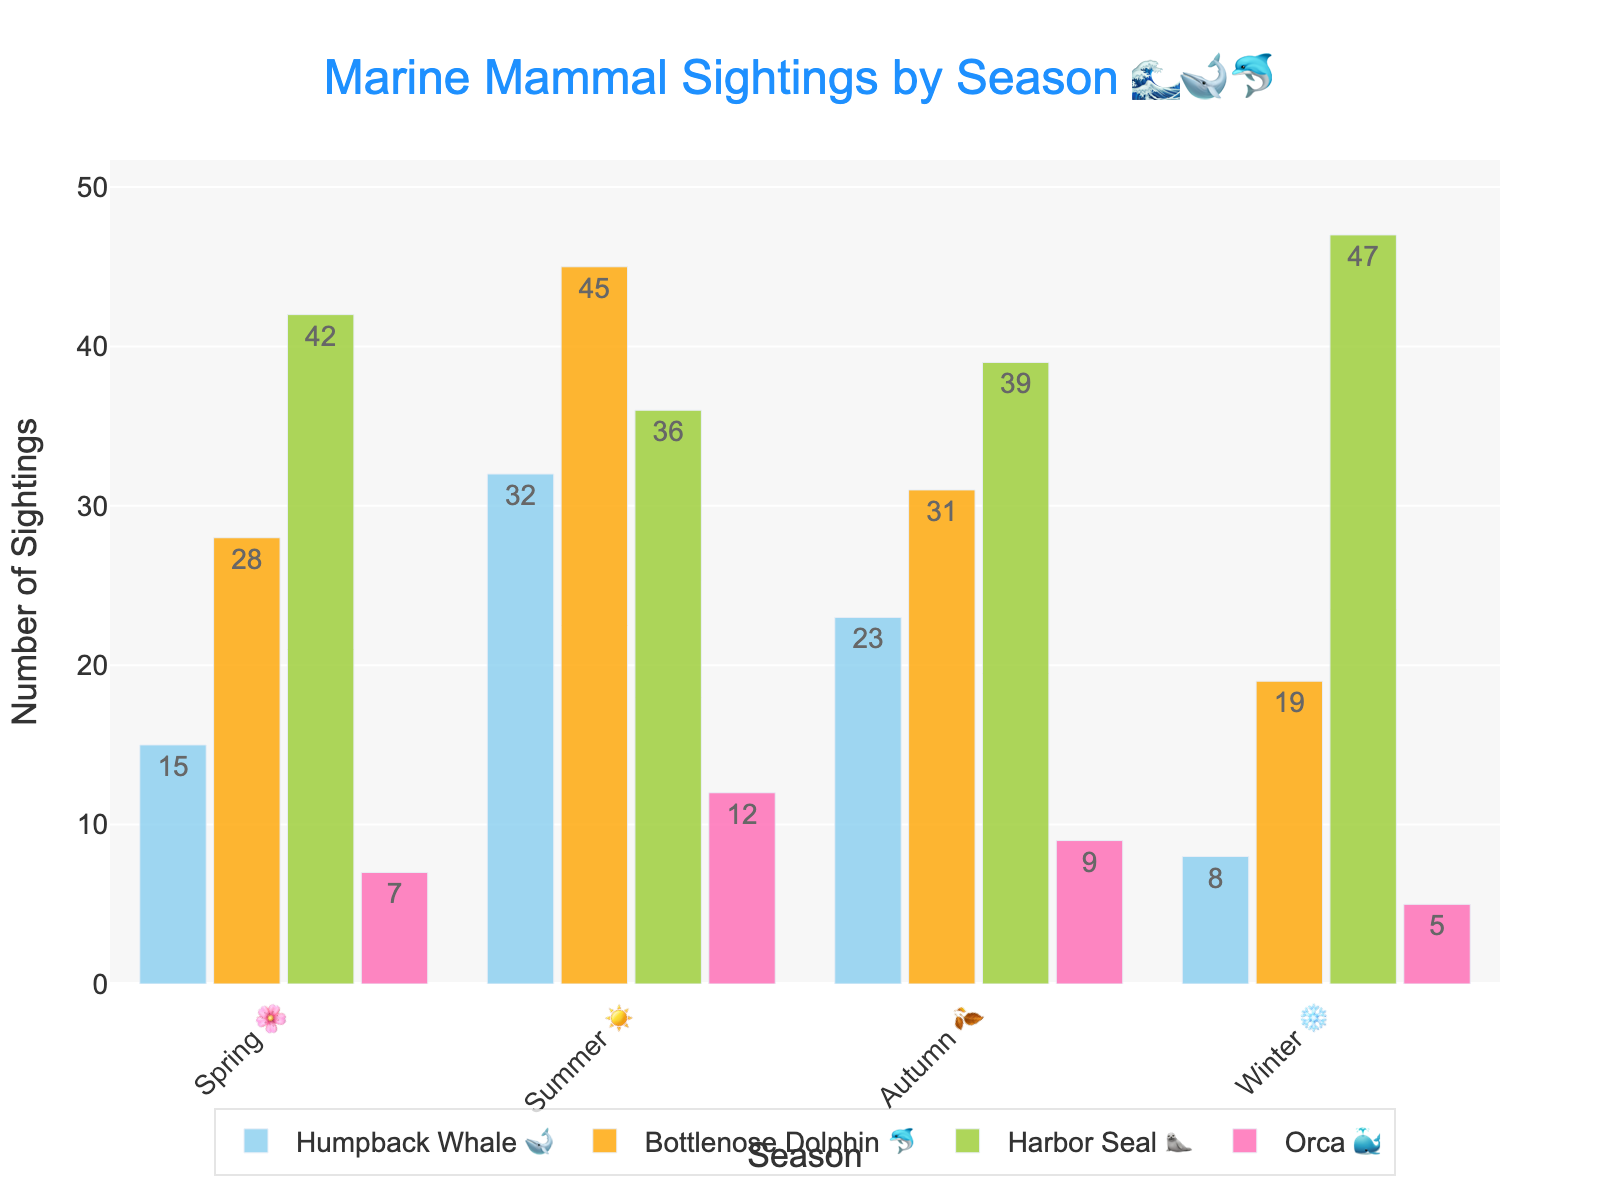How many Harbor Seals 🦭 were sighted in Spring 🌸? Look for the bar corresponding to Harbor Seal 🦭 in the Spring 🌸 season. Read the label or height of the bar for Spring.
Answer: 42 In which season were the most Bottlenose Dolphins 🐬 sighted? Compare the heights of the bars for Bottlenose Dolphins 🐬 across all seasons and identify the tallest one.
Answer: Summer ☀️ What is the total number of marine mammals sighted in Autumn 🍂? Add the counts of each species sighted in Autumn. For Humpback Whale 🐋 (23), Bottlenose Dolphin 🐬 (31), Harbor Seal 🦭 (39), and Orca 🐳 (9), sum these values: 23 + 31 + 39 + 9 = 102
Answer: 102 Which species had the least sightings in Winter ❄️? Compare the bar heights for all species in Winter ❄️ and identify the shortest bar.
Answer: Orca 🐳 How does the number of Orcas 🐳 sighted in Summer ☀️ compare to those sighted in Winter ❄️? Check the height of the Orca bars for Summer ☀️ and Winter ❄️. Compare 12 (Summer) to 5 (Winter).
Answer: Higher in Summer ☀️ Which season had the highest number of Harbor Seals 🦭 sightings? Compare the bars representing Harbor Seal 🦭 sightings across all seasons and find the highest.
Answer: Winter ❄️ By how much did the number of Humpback Whales 🐋 sighted increase from Spring 🌸 to Summer ☀️? Subtract the number of sightings in Spring 🌸 (15) from Summer ☀️ (32): 32 - 15 = 17
Answer: 17 What is the average number of Bottlenose Dolphins 🐬 sighted per season? Sum the sightings for all seasons: 28 + 45 + 31 + 19 = 123. Divide by the number of seasons (4): 123 / 4 = 30.75
Answer: 30.75 Did any species have a decrease in sightings from Summer ☀️ to Autumn 🍂? If yes, which one(s)? Compare the bars for each species between Summer ☀️ and Autumn 🍂. Humpback Whales 🐋 (32 to 23), Bottlenose Dolphins 🐬 (45 to 31), Orcas 🐳 (12 to 9).
Answer: Humpback Whales 🐋, Bottlenose Dolphins 🐬, Orcas 🐳 